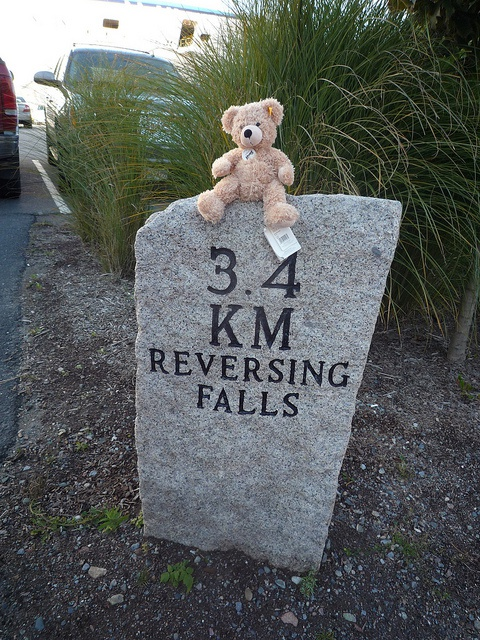Describe the objects in this image and their specific colors. I can see teddy bear in white, darkgray, lightgray, and gray tones, car in white, gray, and darkgray tones, car in white, black, gray, maroon, and darkgray tones, car in white, darkgray, black, lightgray, and gray tones, and traffic light in white, gray, olive, and darkgray tones in this image. 